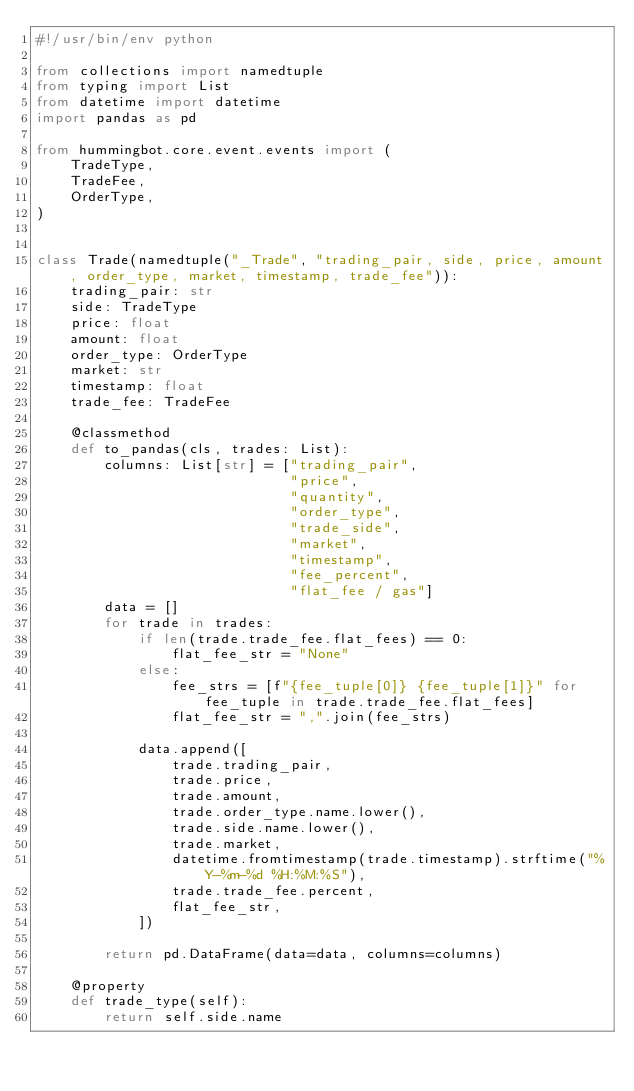Convert code to text. <code><loc_0><loc_0><loc_500><loc_500><_Python_>#!/usr/bin/env python

from collections import namedtuple
from typing import List
from datetime import datetime
import pandas as pd

from hummingbot.core.event.events import (
    TradeType,
    TradeFee,
    OrderType,
)


class Trade(namedtuple("_Trade", "trading_pair, side, price, amount, order_type, market, timestamp, trade_fee")):
    trading_pair: str
    side: TradeType
    price: float
    amount: float
    order_type: OrderType
    market: str
    timestamp: float
    trade_fee: TradeFee

    @classmethod
    def to_pandas(cls, trades: List):
        columns: List[str] = ["trading_pair",
                              "price",
                              "quantity",
                              "order_type",
                              "trade_side",
                              "market",
                              "timestamp",
                              "fee_percent",
                              "flat_fee / gas"]
        data = []
        for trade in trades:
            if len(trade.trade_fee.flat_fees) == 0:
                flat_fee_str = "None"
            else:
                fee_strs = [f"{fee_tuple[0]} {fee_tuple[1]}" for fee_tuple in trade.trade_fee.flat_fees]
                flat_fee_str = ",".join(fee_strs)

            data.append([
                trade.trading_pair,
                trade.price,
                trade.amount,
                trade.order_type.name.lower(),
                trade.side.name.lower(),
                trade.market,
                datetime.fromtimestamp(trade.timestamp).strftime("%Y-%m-%d %H:%M:%S"),
                trade.trade_fee.percent,
                flat_fee_str,
            ])

        return pd.DataFrame(data=data, columns=columns)

    @property
    def trade_type(self):
        return self.side.name
</code> 